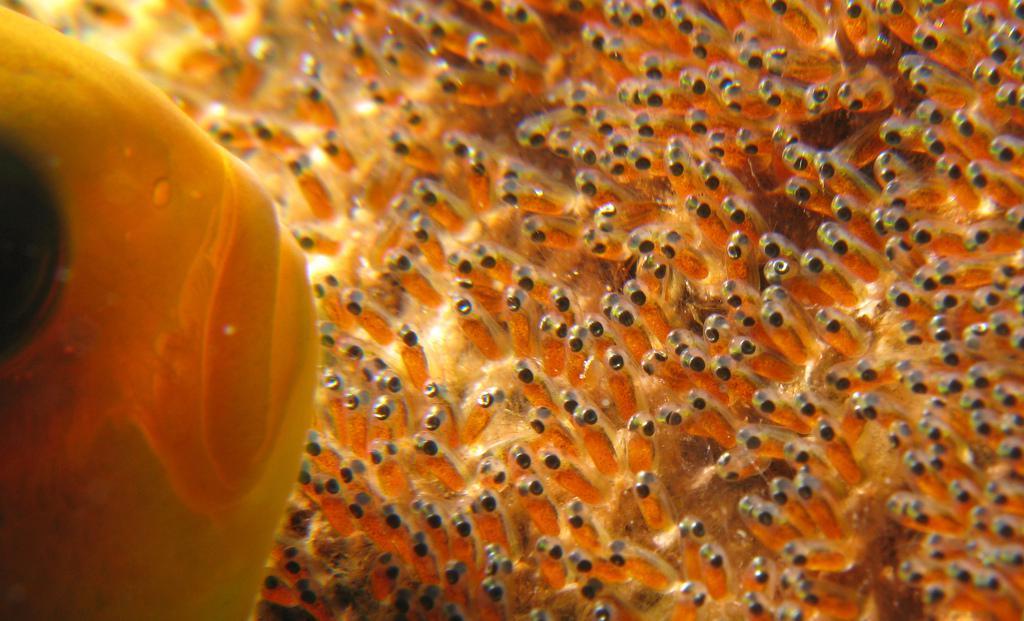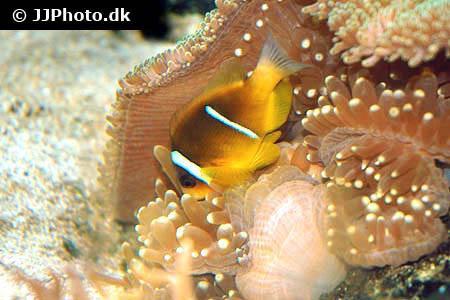The first image is the image on the left, the second image is the image on the right. Given the left and right images, does the statement "One image shows a single orange-yellow fish with two white stripes above anemone, and no image contains fish that are not yellowish." hold true? Answer yes or no. Yes. The first image is the image on the left, the second image is the image on the right. Given the left and right images, does the statement "There is exactly one fish in both images." hold true? Answer yes or no. Yes. 